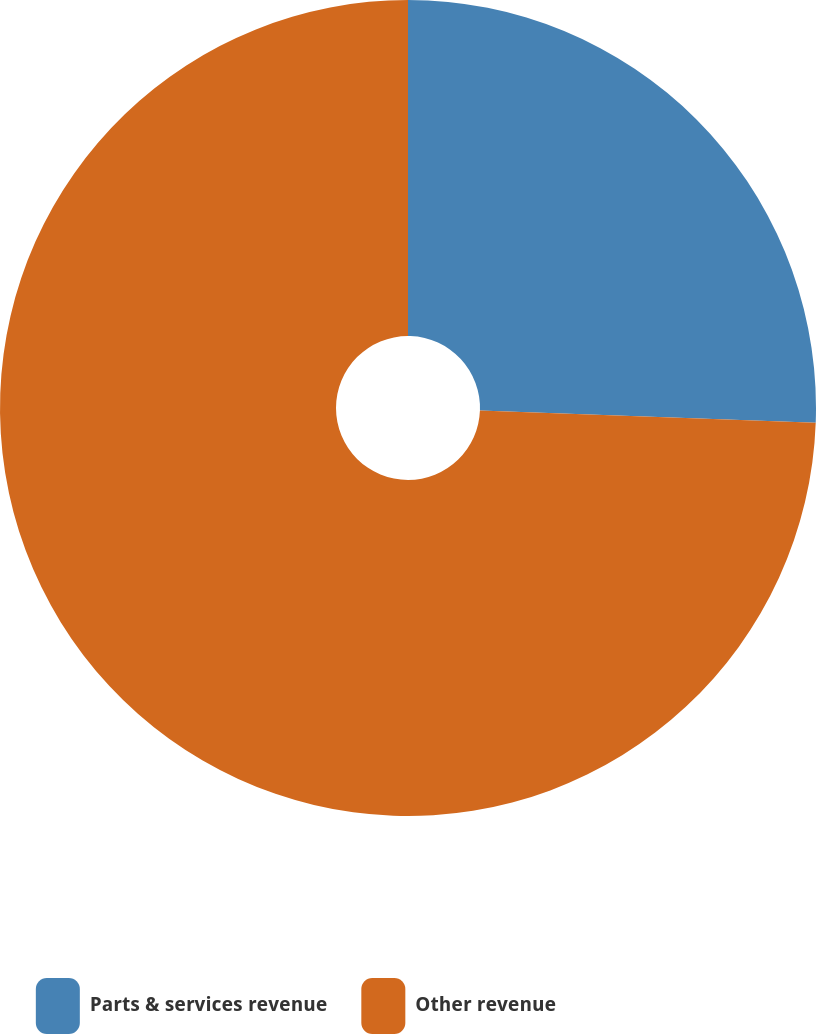<chart> <loc_0><loc_0><loc_500><loc_500><pie_chart><fcel>Parts & services revenue<fcel>Other revenue<nl><fcel>25.58%<fcel>74.42%<nl></chart> 